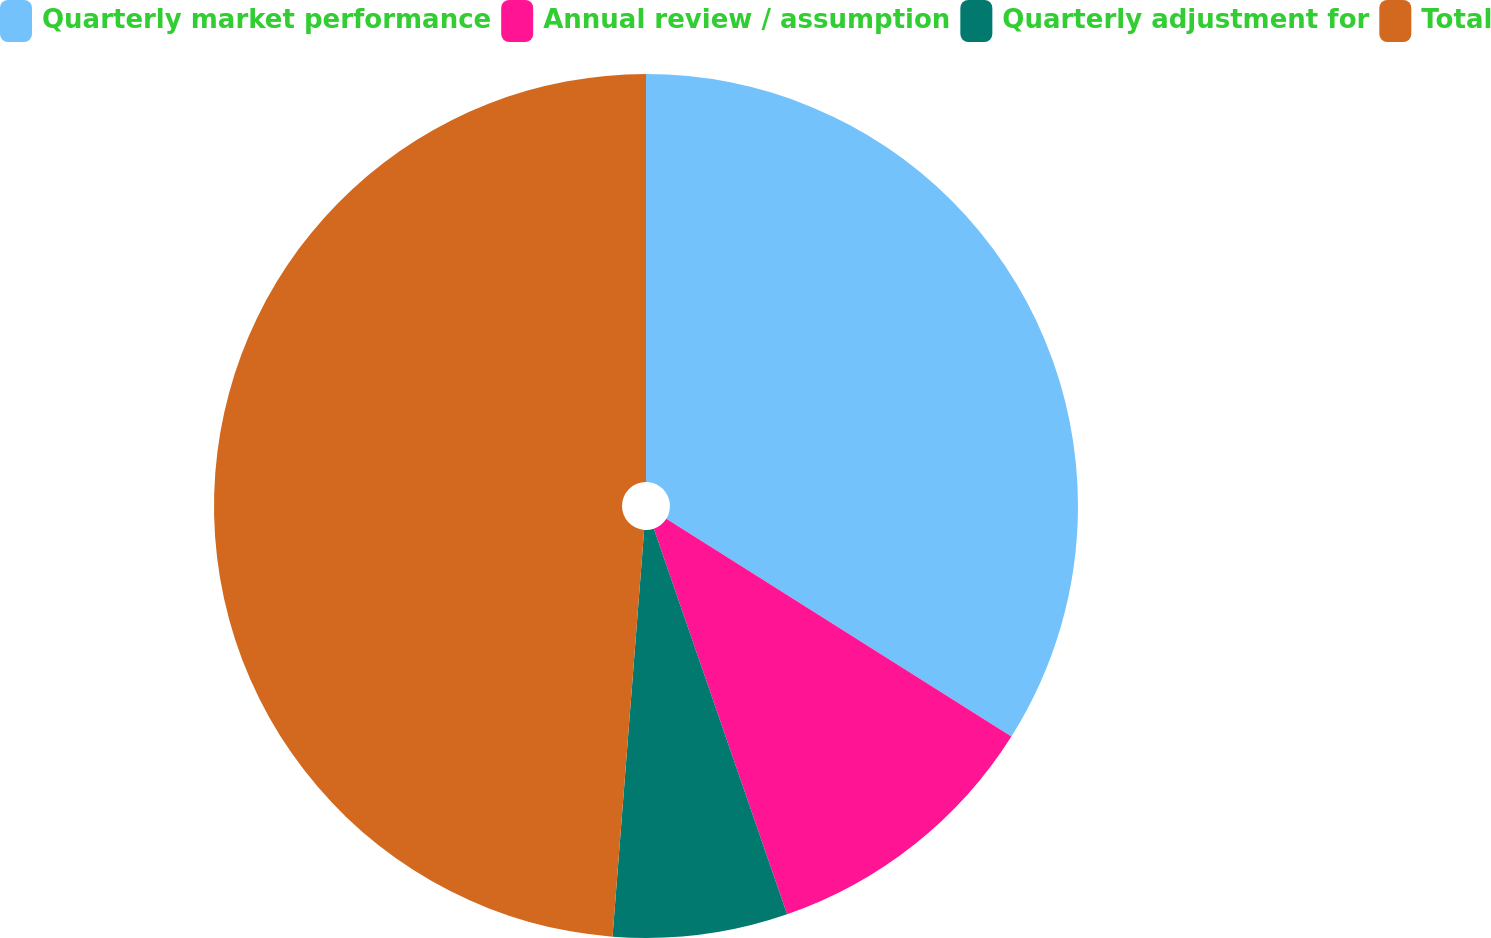<chart> <loc_0><loc_0><loc_500><loc_500><pie_chart><fcel>Quarterly market performance<fcel>Annual review / assumption<fcel>Quarterly adjustment for<fcel>Total<nl><fcel>33.96%<fcel>10.75%<fcel>6.53%<fcel>48.77%<nl></chart> 